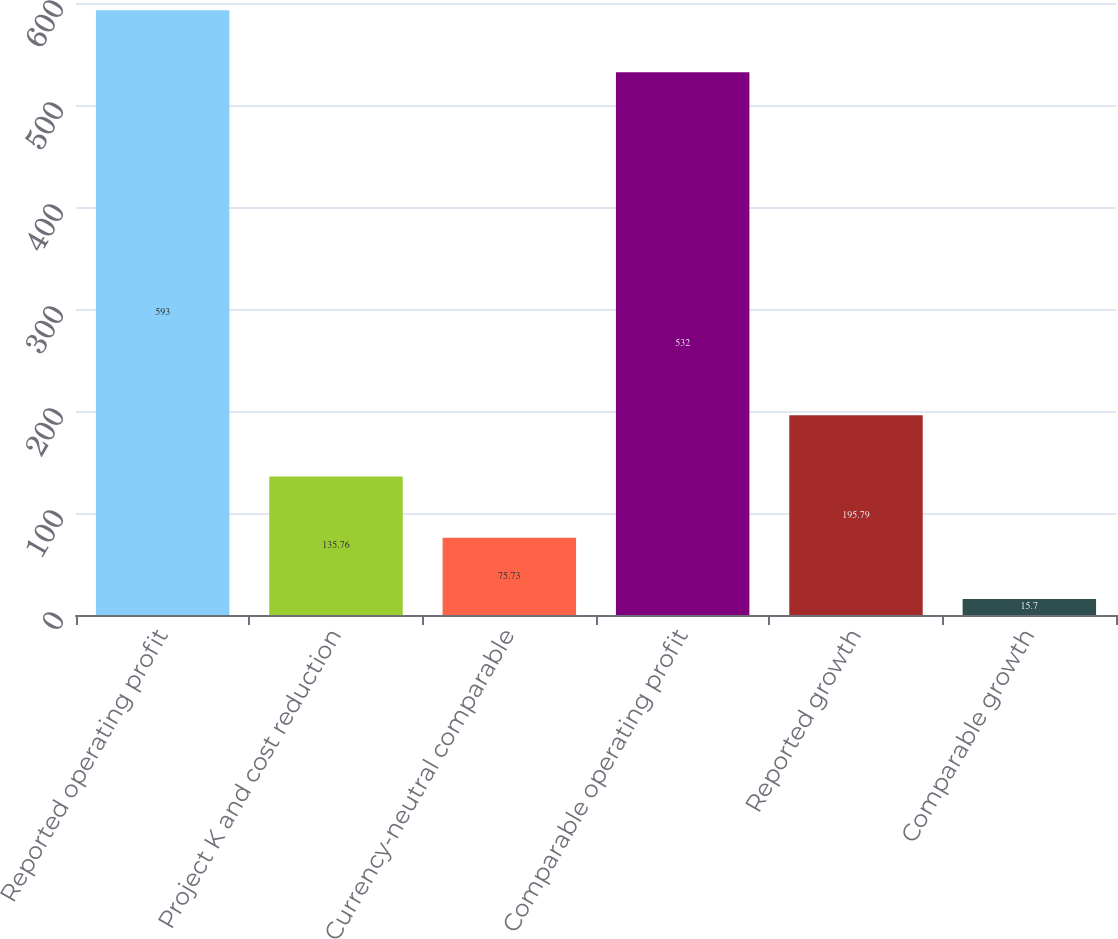Convert chart to OTSL. <chart><loc_0><loc_0><loc_500><loc_500><bar_chart><fcel>Reported operating profit<fcel>Project K and cost reduction<fcel>Currency-neutral comparable<fcel>Comparable operating profit<fcel>Reported growth<fcel>Comparable growth<nl><fcel>593<fcel>135.76<fcel>75.73<fcel>532<fcel>195.79<fcel>15.7<nl></chart> 